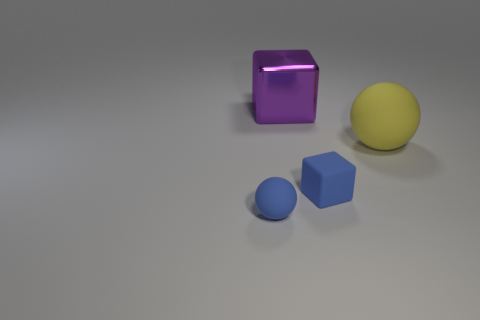Add 2 big matte objects. How many objects exist? 6 Subtract all purple cubes. How many cubes are left? 1 Subtract all cyan cubes. Subtract all purple balls. How many cubes are left? 2 Subtract all blue balls. How many green cubes are left? 0 Subtract all big yellow objects. Subtract all matte spheres. How many objects are left? 1 Add 1 large yellow rubber balls. How many large yellow rubber balls are left? 2 Add 3 big purple objects. How many big purple objects exist? 4 Subtract 0 red cubes. How many objects are left? 4 Subtract 1 spheres. How many spheres are left? 1 